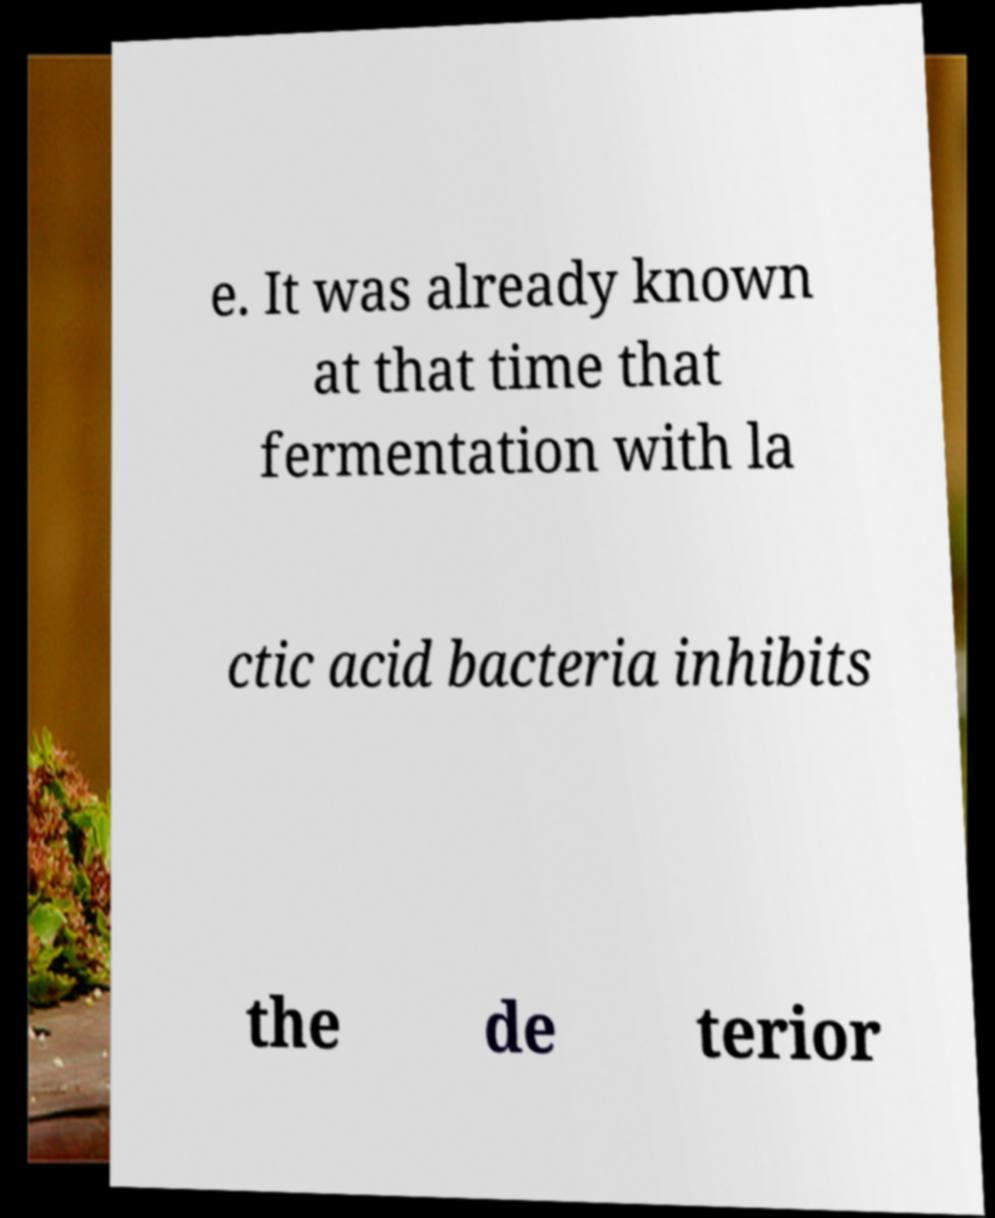Please read and relay the text visible in this image. What does it say? e. It was already known at that time that fermentation with la ctic acid bacteria inhibits the de terior 